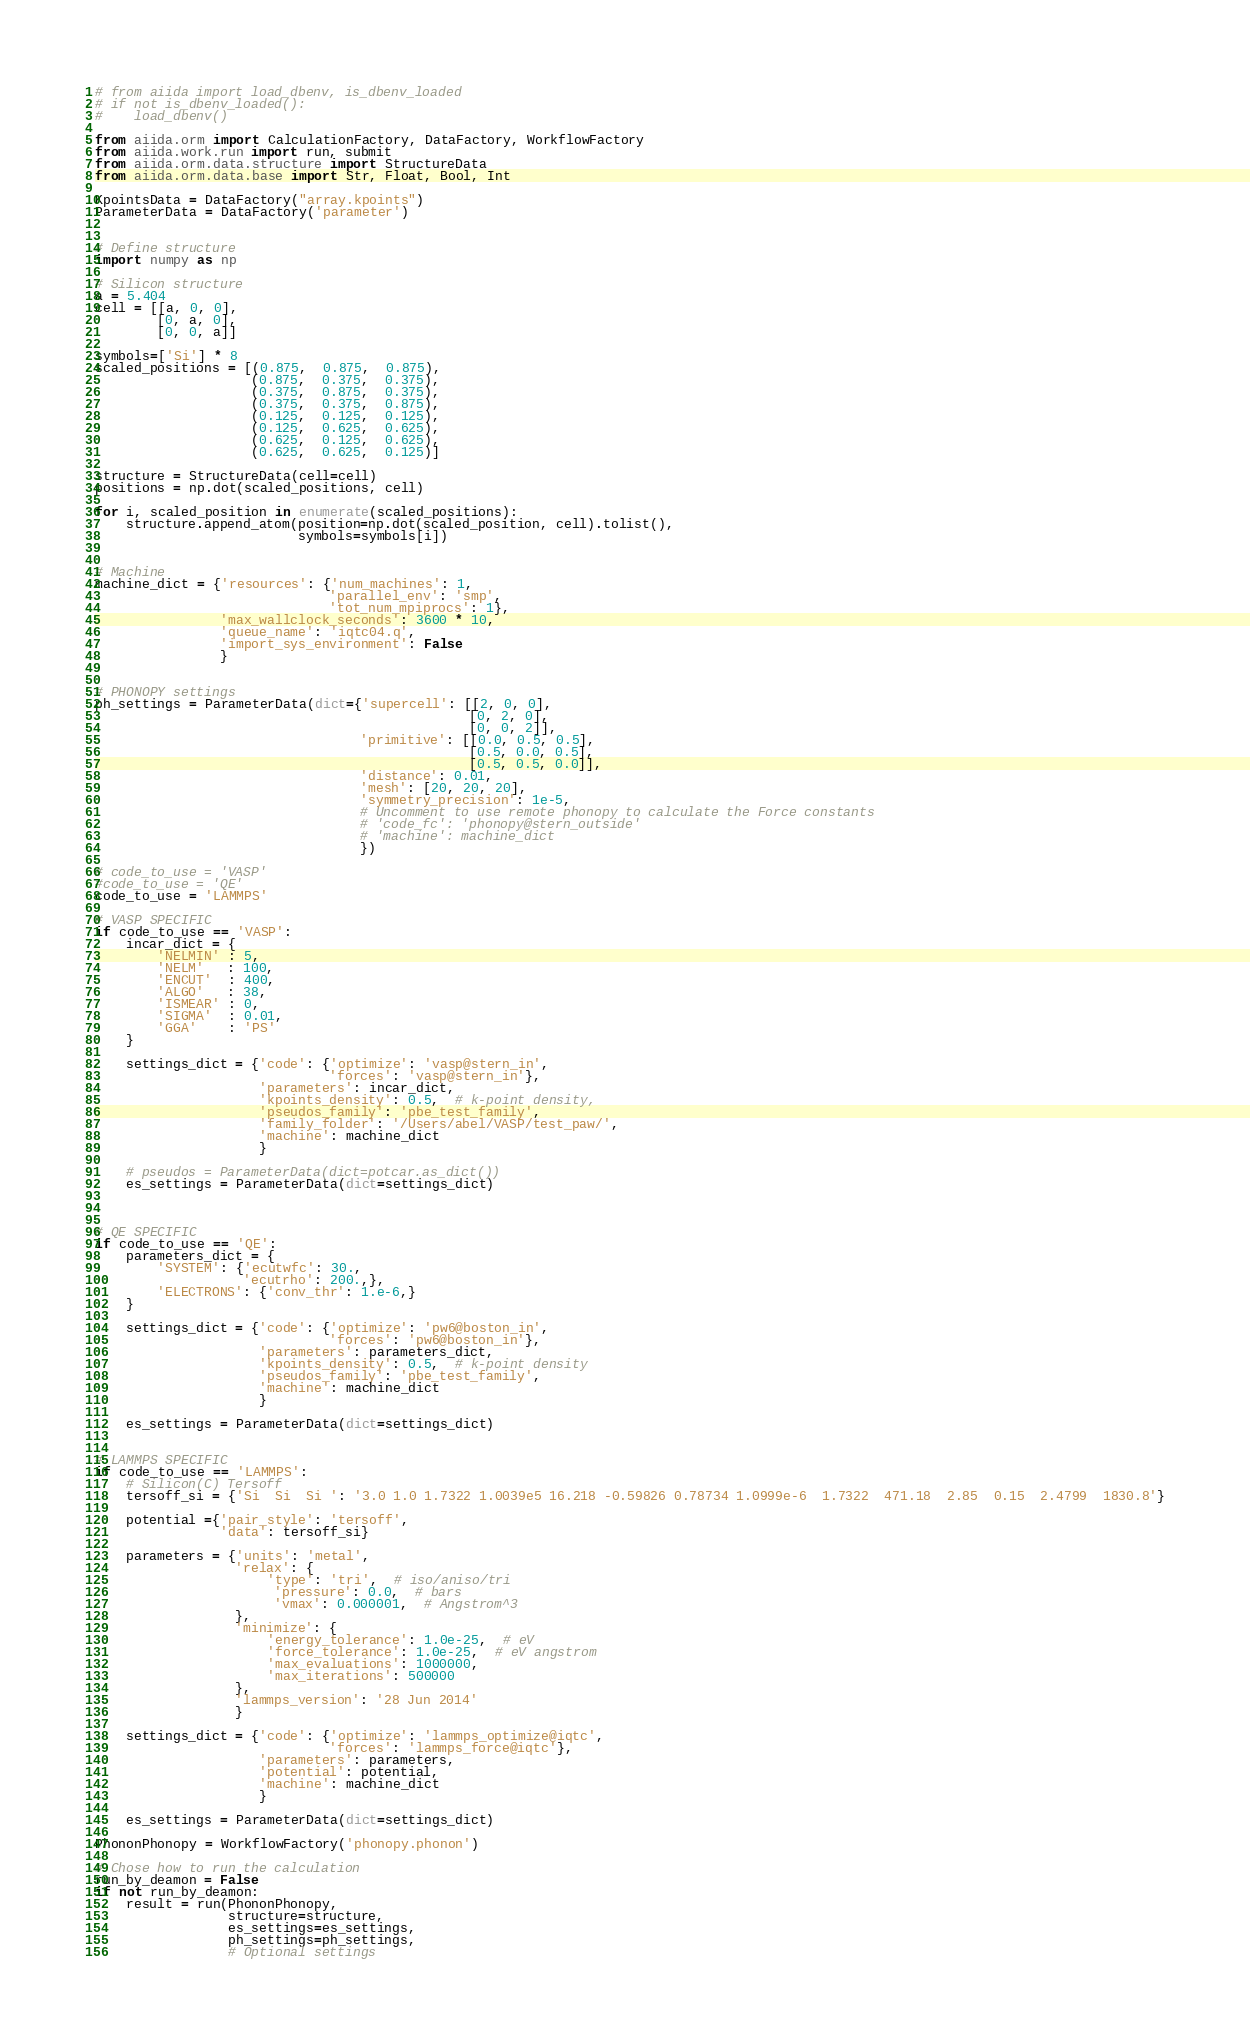<code> <loc_0><loc_0><loc_500><loc_500><_Python_># from aiida import load_dbenv, is_dbenv_loaded
# if not is_dbenv_loaded():
#    load_dbenv()

from aiida.orm import CalculationFactory, DataFactory, WorkflowFactory
from aiida.work.run import run, submit
from aiida.orm.data.structure import StructureData
from aiida.orm.data.base import Str, Float, Bool, Int

KpointsData = DataFactory("array.kpoints")
ParameterData = DataFactory('parameter')


# Define structure
import numpy as np

# Silicon structure
a = 5.404
cell = [[a, 0, 0],
        [0, a, 0],
        [0, 0, a]]

symbols=['Si'] * 8
scaled_positions = [(0.875,  0.875,  0.875),
                    (0.875,  0.375,  0.375),
                    (0.375,  0.875,  0.375),
                    (0.375,  0.375,  0.875),
                    (0.125,  0.125,  0.125),
                    (0.125,  0.625,  0.625),
                    (0.625,  0.125,  0.625),
                    (0.625,  0.625,  0.125)]

structure = StructureData(cell=cell)
positions = np.dot(scaled_positions, cell)

for i, scaled_position in enumerate(scaled_positions):
    structure.append_atom(position=np.dot(scaled_position, cell).tolist(),
                          symbols=symbols[i])


# Machine
machine_dict = {'resources': {'num_machines': 1,
                              'parallel_env': 'smp',
                              'tot_num_mpiprocs': 1},
                'max_wallclock_seconds': 3600 * 10,
                'queue_name': 'iqtc04.q',
                'import_sys_environment': False
                }


# PHONOPY settings
ph_settings = ParameterData(dict={'supercell': [[2, 0, 0],
                                                [0, 2, 0],
                                                [0, 0, 2]],
                                  'primitive': [[0.0, 0.5, 0.5],
                                                [0.5, 0.0, 0.5],
                                                [0.5, 0.5, 0.0]],
                                  'distance': 0.01,
                                  'mesh': [20, 20, 20],
                                  'symmetry_precision': 1e-5,
                                  # Uncomment to use remote phonopy to calculate the Force constants
                                  # 'code_fc': 'phonopy@stern_outside'
                                  # 'machine': machine_dict
                                  })

# code_to_use = 'VASP'
#code_to_use = 'QE'
code_to_use = 'LAMMPS'

# VASP SPECIFIC
if code_to_use == 'VASP':
    incar_dict = {
        'NELMIN' : 5,
        'NELM'   : 100,
        'ENCUT'  : 400,
        'ALGO'   : 38,
        'ISMEAR' : 0,
        'SIGMA'  : 0.01,
        'GGA'    : 'PS'
    }

    settings_dict = {'code': {'optimize': 'vasp@stern_in',
                              'forces': 'vasp@stern_in'},
                     'parameters': incar_dict,
                     'kpoints_density': 0.5,  # k-point density,
                     'pseudos_family': 'pbe_test_family',
                     'family_folder': '/Users/abel/VASP/test_paw/',
                     'machine': machine_dict
                     }

    # pseudos = ParameterData(dict=potcar.as_dict())
    es_settings = ParameterData(dict=settings_dict)



# QE SPECIFIC
if code_to_use == 'QE':
    parameters_dict = {
        'SYSTEM': {'ecutwfc': 30.,
                   'ecutrho': 200.,},
        'ELECTRONS': {'conv_thr': 1.e-6,}
    }

    settings_dict = {'code': {'optimize': 'pw6@boston_in',
                              'forces': 'pw6@boston_in'},
                     'parameters': parameters_dict,
                     'kpoints_density': 0.5,  # k-point density
                     'pseudos_family': 'pbe_test_family',
                     'machine': machine_dict
                     }

    es_settings = ParameterData(dict=settings_dict)


# LAMMPS SPECIFIC
if code_to_use == 'LAMMPS':
    # Silicon(C) Tersoff
    tersoff_si = {'Si  Si  Si ': '3.0 1.0 1.7322 1.0039e5 16.218 -0.59826 0.78734 1.0999e-6  1.7322  471.18  2.85  0.15  2.4799  1830.8'}

    potential ={'pair_style': 'tersoff',
                'data': tersoff_si}

    parameters = {'units': 'metal',
                  'relax': {
                      'type': 'tri',  # iso/aniso/tri
                       'pressure': 0.0,  # bars
                       'vmax': 0.000001,  # Angstrom^3
                  },
                  'minimize': {
                      'energy_tolerance': 1.0e-25,  # eV
                      'force_tolerance': 1.0e-25,  # eV angstrom
                      'max_evaluations': 1000000,
                      'max_iterations': 500000
                  },
                  'lammps_version': '28 Jun 2014'
                  }

    settings_dict = {'code': {'optimize': 'lammps_optimize@iqtc',
                              'forces': 'lammps_force@iqtc'},
                     'parameters': parameters,
                     'potential': potential,
                     'machine': machine_dict
                     }

    es_settings = ParameterData(dict=settings_dict)

PhononPhonopy = WorkflowFactory('phonopy.phonon')

# Chose how to run the calculation
run_by_deamon = False
if not run_by_deamon:
    result = run(PhononPhonopy,
                 structure=structure,
                 es_settings=es_settings,
                 ph_settings=ph_settings,
                 # Optional settings</code> 